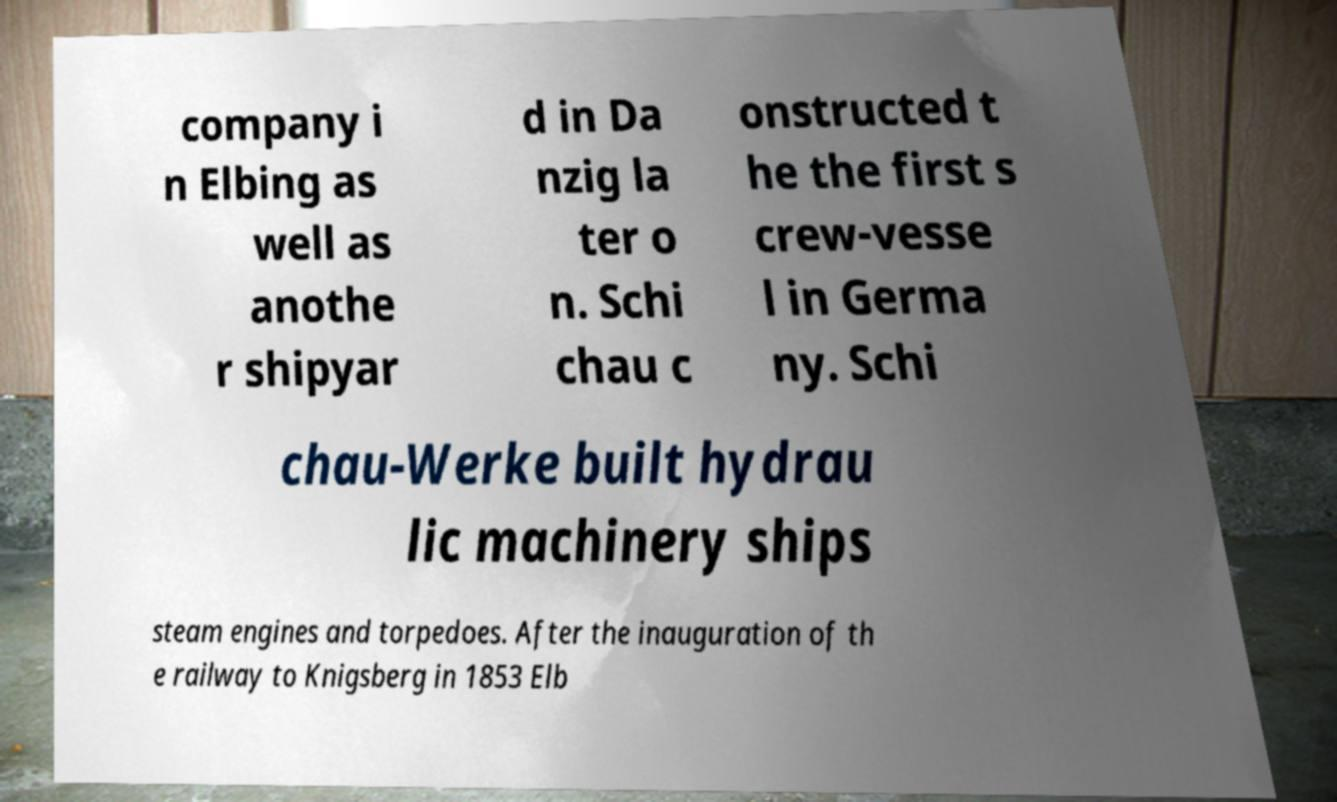Could you extract and type out the text from this image? company i n Elbing as well as anothe r shipyar d in Da nzig la ter o n. Schi chau c onstructed t he the first s crew-vesse l in Germa ny. Schi chau-Werke built hydrau lic machinery ships steam engines and torpedoes. After the inauguration of th e railway to Knigsberg in 1853 Elb 